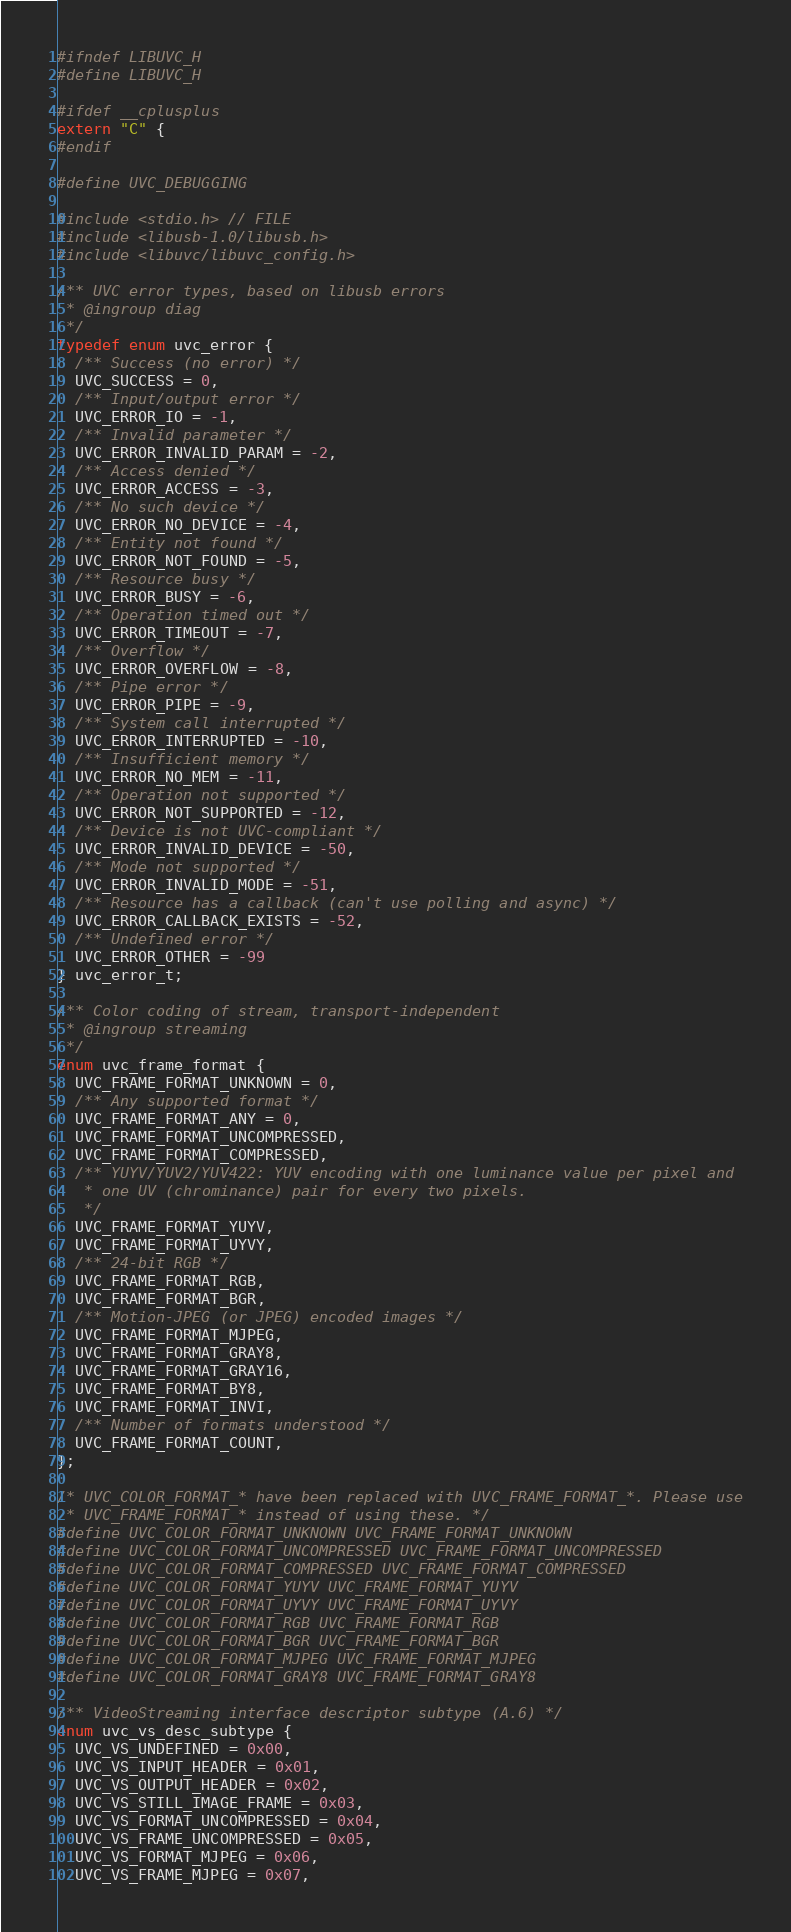Convert code to text. <code><loc_0><loc_0><loc_500><loc_500><_C_>#ifndef LIBUVC_H
#define LIBUVC_H

#ifdef __cplusplus
extern "C" {
#endif    	

#define UVC_DEBUGGING

#include <stdio.h> // FILE
#include <libusb-1.0/libusb.h>
#include <libuvc/libuvc_config.h>

/** UVC error types, based on libusb errors
 * @ingroup diag
 */
typedef enum uvc_error {
  /** Success (no error) */
  UVC_SUCCESS = 0,
  /** Input/output error */
  UVC_ERROR_IO = -1,
  /** Invalid parameter */
  UVC_ERROR_INVALID_PARAM = -2,
  /** Access denied */
  UVC_ERROR_ACCESS = -3,
  /** No such device */
  UVC_ERROR_NO_DEVICE = -4,
  /** Entity not found */
  UVC_ERROR_NOT_FOUND = -5,
  /** Resource busy */
  UVC_ERROR_BUSY = -6,
  /** Operation timed out */
  UVC_ERROR_TIMEOUT = -7,
  /** Overflow */
  UVC_ERROR_OVERFLOW = -8,
  /** Pipe error */
  UVC_ERROR_PIPE = -9,
  /** System call interrupted */
  UVC_ERROR_INTERRUPTED = -10,
  /** Insufficient memory */
  UVC_ERROR_NO_MEM = -11,
  /** Operation not supported */
  UVC_ERROR_NOT_SUPPORTED = -12,
  /** Device is not UVC-compliant */
  UVC_ERROR_INVALID_DEVICE = -50,
  /** Mode not supported */
  UVC_ERROR_INVALID_MODE = -51,
  /** Resource has a callback (can't use polling and async) */
  UVC_ERROR_CALLBACK_EXISTS = -52,
  /** Undefined error */
  UVC_ERROR_OTHER = -99
} uvc_error_t;

/** Color coding of stream, transport-independent
 * @ingroup streaming
 */
enum uvc_frame_format {
  UVC_FRAME_FORMAT_UNKNOWN = 0,
  /** Any supported format */
  UVC_FRAME_FORMAT_ANY = 0,
  UVC_FRAME_FORMAT_UNCOMPRESSED,
  UVC_FRAME_FORMAT_COMPRESSED,
  /** YUYV/YUV2/YUV422: YUV encoding with one luminance value per pixel and
   * one UV (chrominance) pair for every two pixels.
   */
  UVC_FRAME_FORMAT_YUYV,
  UVC_FRAME_FORMAT_UYVY,
  /** 24-bit RGB */
  UVC_FRAME_FORMAT_RGB,
  UVC_FRAME_FORMAT_BGR,
  /** Motion-JPEG (or JPEG) encoded images */
  UVC_FRAME_FORMAT_MJPEG,
  UVC_FRAME_FORMAT_GRAY8,
  UVC_FRAME_FORMAT_GRAY16,
  UVC_FRAME_FORMAT_BY8,
  UVC_FRAME_FORMAT_INVI,
  /** Number of formats understood */
  UVC_FRAME_FORMAT_COUNT,
};

/* UVC_COLOR_FORMAT_* have been replaced with UVC_FRAME_FORMAT_*. Please use
 * UVC_FRAME_FORMAT_* instead of using these. */
#define UVC_COLOR_FORMAT_UNKNOWN UVC_FRAME_FORMAT_UNKNOWN
#define UVC_COLOR_FORMAT_UNCOMPRESSED UVC_FRAME_FORMAT_UNCOMPRESSED
#define UVC_COLOR_FORMAT_COMPRESSED UVC_FRAME_FORMAT_COMPRESSED
#define UVC_COLOR_FORMAT_YUYV UVC_FRAME_FORMAT_YUYV
#define UVC_COLOR_FORMAT_UYVY UVC_FRAME_FORMAT_UYVY
#define UVC_COLOR_FORMAT_RGB UVC_FRAME_FORMAT_RGB
#define UVC_COLOR_FORMAT_BGR UVC_FRAME_FORMAT_BGR
#define UVC_COLOR_FORMAT_MJPEG UVC_FRAME_FORMAT_MJPEG
#define UVC_COLOR_FORMAT_GRAY8 UVC_FRAME_FORMAT_GRAY8

/** VideoStreaming interface descriptor subtype (A.6) */
enum uvc_vs_desc_subtype {
  UVC_VS_UNDEFINED = 0x00,
  UVC_VS_INPUT_HEADER = 0x01,
  UVC_VS_OUTPUT_HEADER = 0x02,
  UVC_VS_STILL_IMAGE_FRAME = 0x03,
  UVC_VS_FORMAT_UNCOMPRESSED = 0x04,
  UVC_VS_FRAME_UNCOMPRESSED = 0x05,
  UVC_VS_FORMAT_MJPEG = 0x06,
  UVC_VS_FRAME_MJPEG = 0x07,</code> 